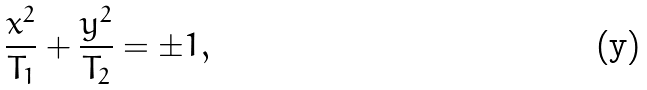Convert formula to latex. <formula><loc_0><loc_0><loc_500><loc_500>\frac { x ^ { 2 } } { T _ { 1 } } + \frac { y ^ { 2 } } { T _ { 2 } } = \pm 1 ,</formula> 